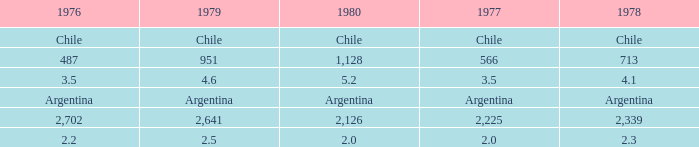What is 1980 when 1979 is 951? 1128.0. 